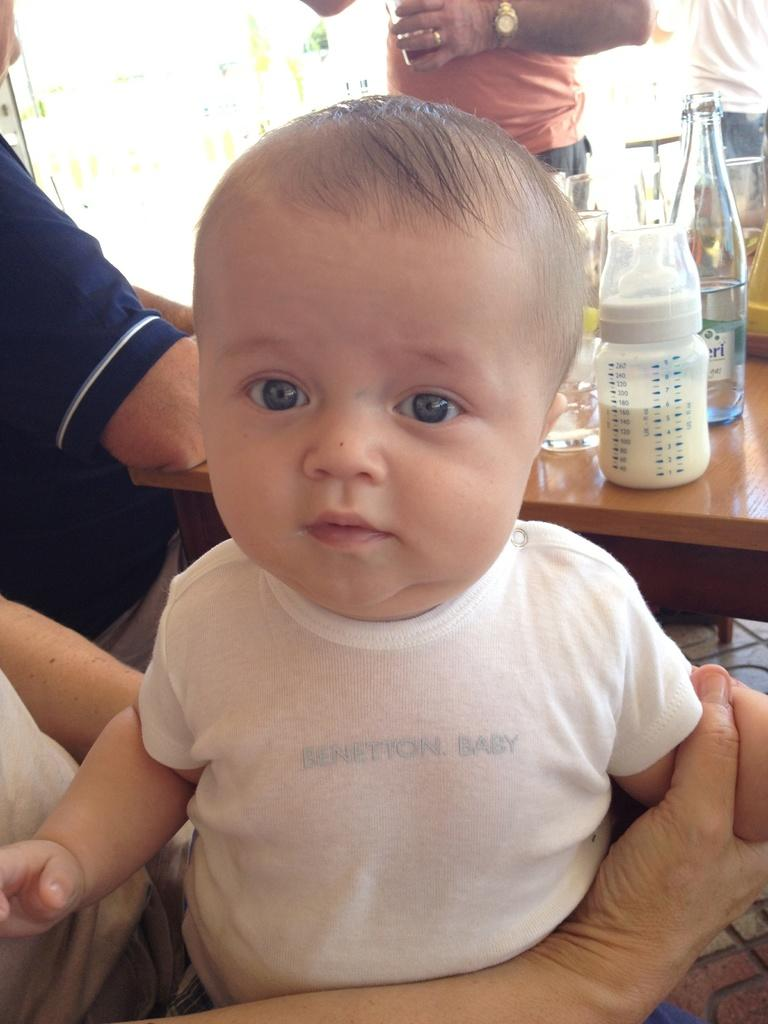Who or what is present in the image? There are people in the image. What objects can be seen on the table in the image? There is a glass bottle and a milk bottle on the table. What type of rice can be seen in the image? There is no rice present in the image. What is the time displayed on the watch in the image? There is no watch present in the image. 